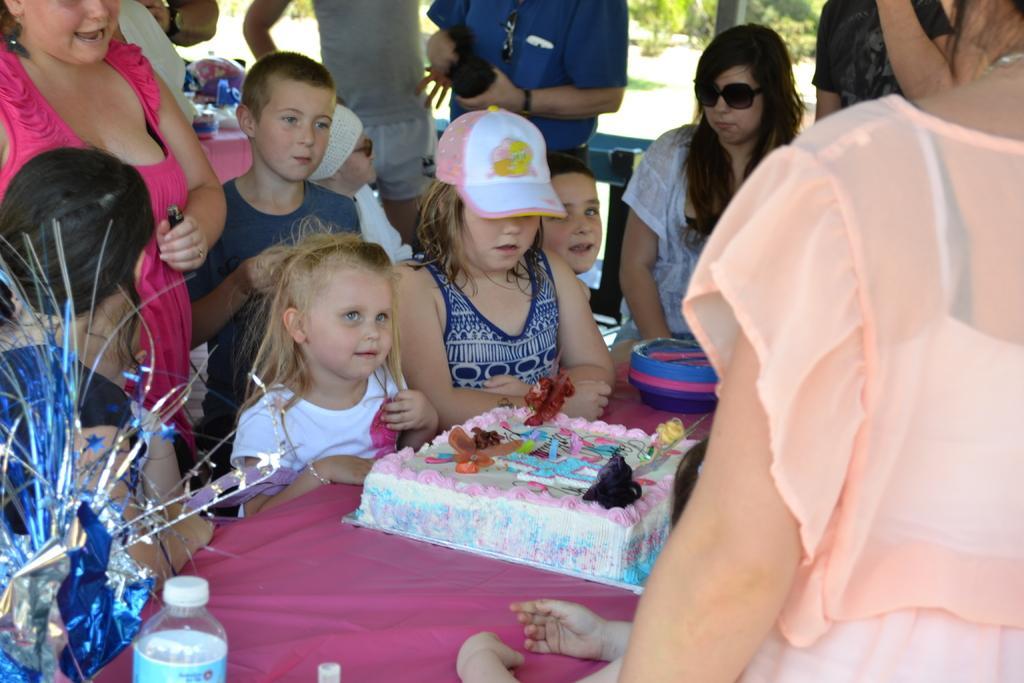Could you give a brief overview of what you see in this image? In front of the table there is a cake and some other objects, around the table there are a few kids and adults standing and sitting in chairs, behind them there is another table with some objects on it, in the background of the image there is a chair, wooden fence, metal rod and trees. 